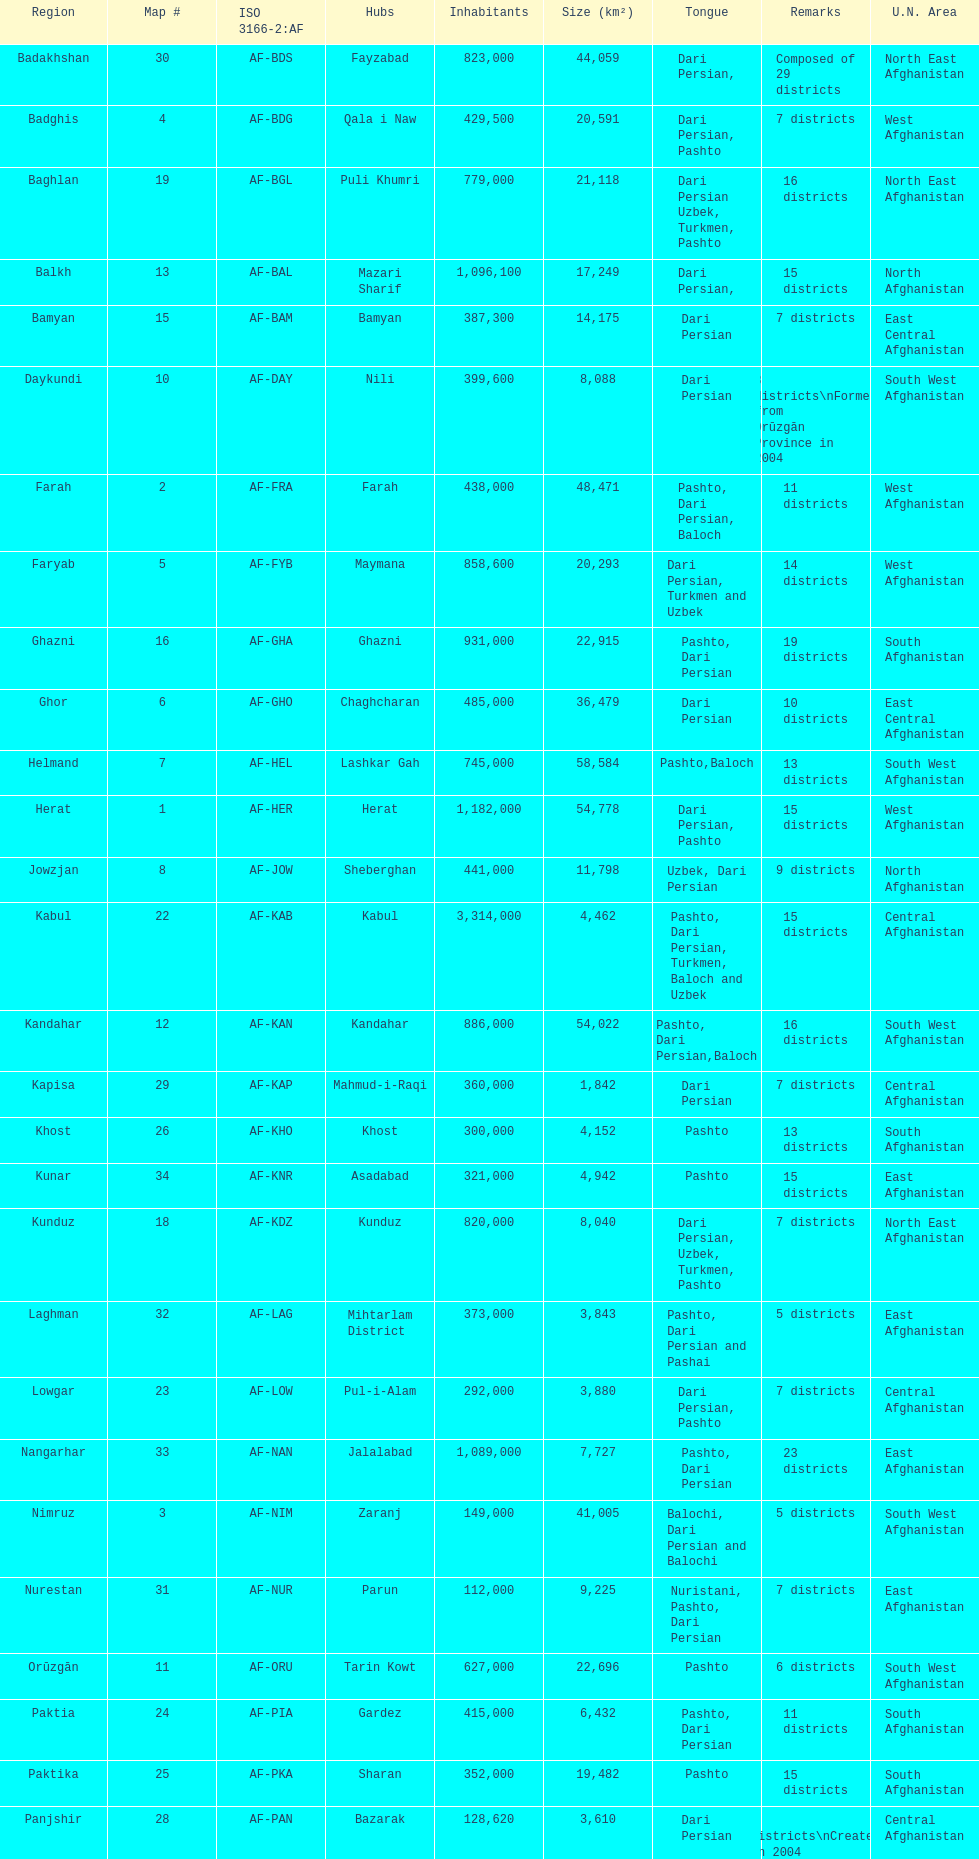How many provinces have pashto as one of their languages 20. 